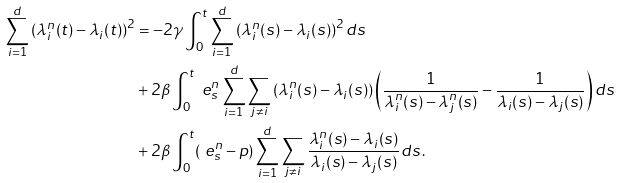Convert formula to latex. <formula><loc_0><loc_0><loc_500><loc_500>\sum _ { i = 1 } ^ { d } \left ( \lambda _ { i } ^ { n } ( t ) - \lambda _ { i } ( t ) \right ) ^ { 2 } & = - 2 \gamma \int _ { 0 } ^ { t } \sum _ { i = 1 } ^ { d } \left ( \lambda _ { i } ^ { n } ( s ) - \lambda _ { i } ( s ) \right ) ^ { 2 } d s \\ & + 2 \beta \int _ { 0 } ^ { t } \ e _ { s } ^ { n } \sum _ { i = 1 } ^ { d } \sum _ { j \not = i } \left ( \lambda _ { i } ^ { n } ( s ) - \lambda _ { i } ( s ) \right ) \left ( \frac { 1 } { \lambda _ { i } ^ { n } ( s ) - \lambda _ { j } ^ { n } ( s ) } - \frac { 1 } { \lambda _ { i } ( s ) - \lambda _ { j } ( s ) } \right ) d s \\ & + 2 \beta \int _ { 0 } ^ { t } ( \ e _ { s } ^ { n } - p ) \sum _ { i = 1 } ^ { d } \sum _ { j \not = i } \frac { \lambda _ { i } ^ { n } ( s ) - \lambda _ { i } ( s ) } { \lambda _ { i } ( s ) - \lambda _ { j } ( s ) } d s \, .</formula> 